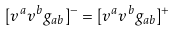Convert formula to latex. <formula><loc_0><loc_0><loc_500><loc_500>[ v ^ { a } v ^ { b } g _ { a b } ] ^ { - } = [ v ^ { a } v ^ { b } g _ { a b } ] ^ { + }</formula> 